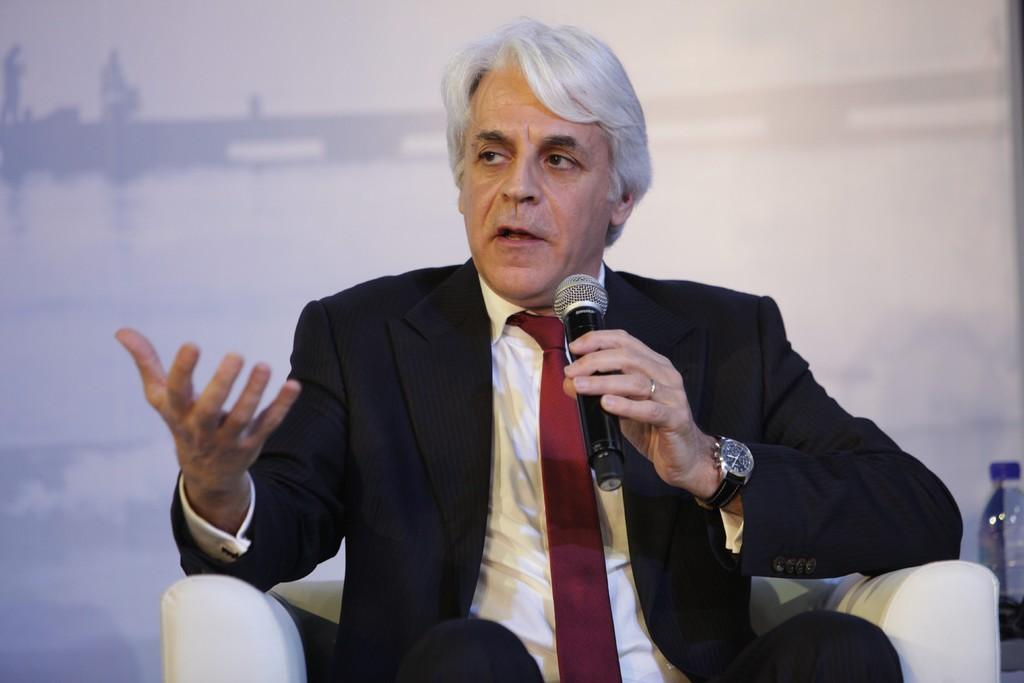What is the person in the image wearing? The person is wearing a suit in the image. Where is the person sitting? The person is sitting on a white sofa. What is the person doing while sitting on the sofa? The person is speaking in front of a mic. What is the color of the background in the image? The background of the image is white. How many pizzas are on the white sofa in the image? There are no pizzas present in the image. What type of basin can be seen in the background of the image? There is no basin visible in the background of the image. 